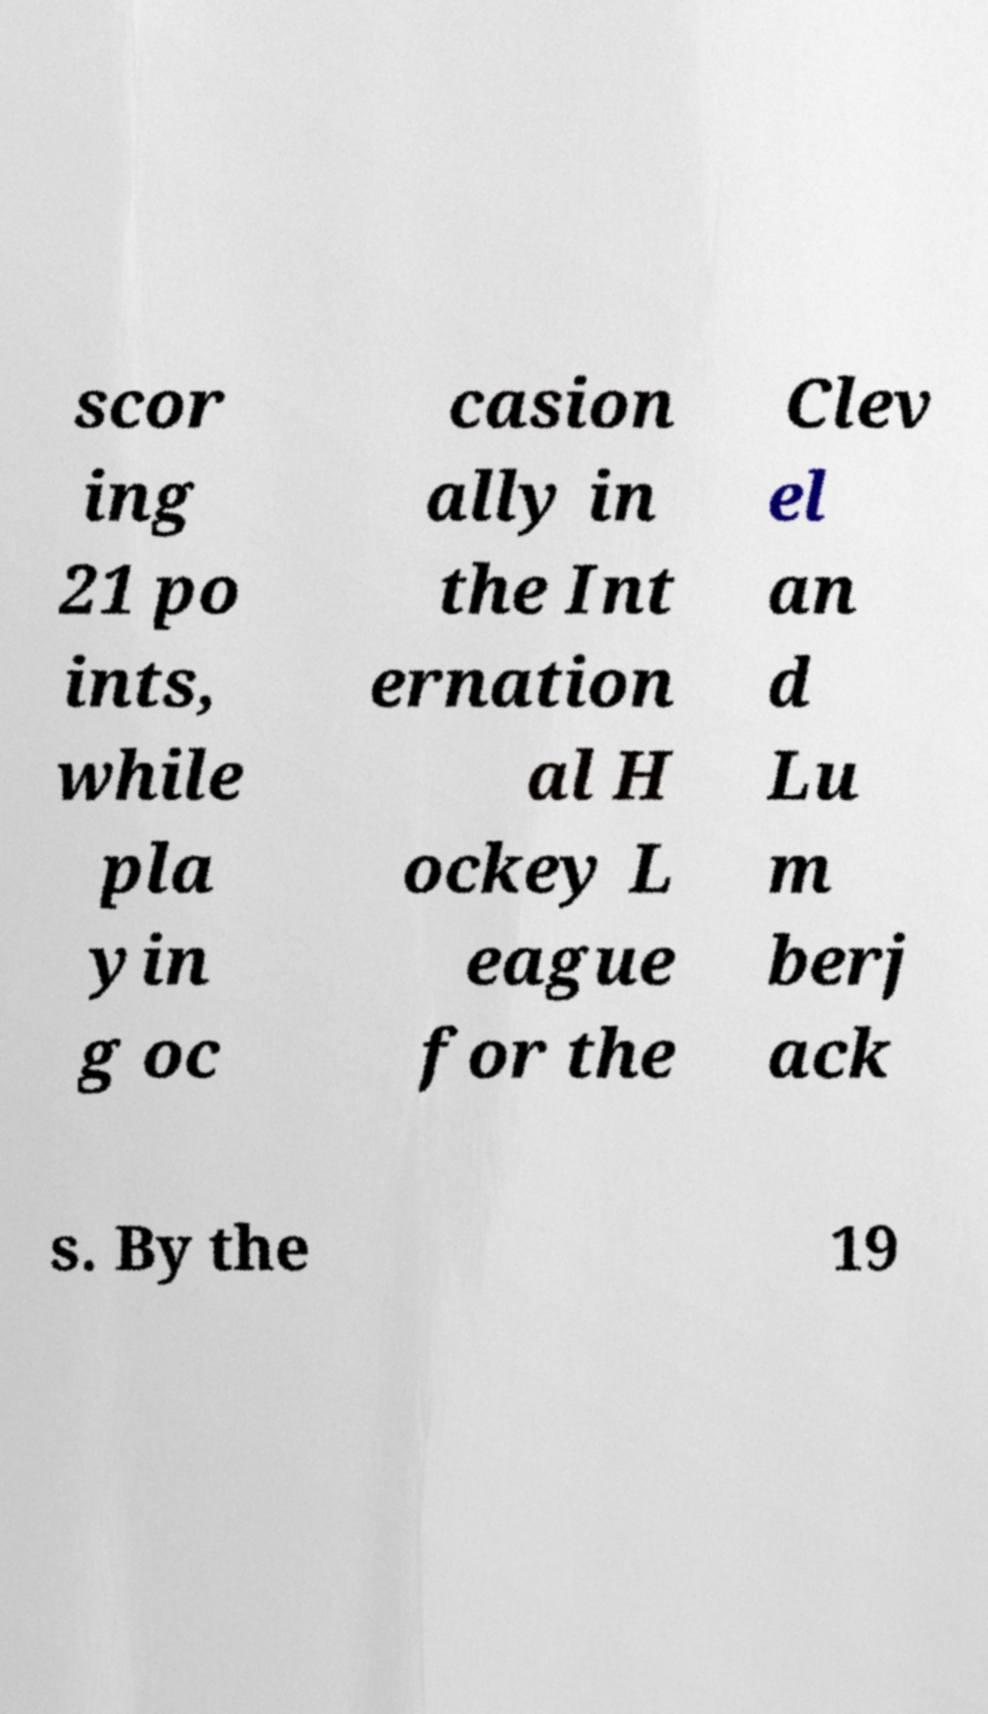What messages or text are displayed in this image? I need them in a readable, typed format. scor ing 21 po ints, while pla yin g oc casion ally in the Int ernation al H ockey L eague for the Clev el an d Lu m berj ack s. By the 19 